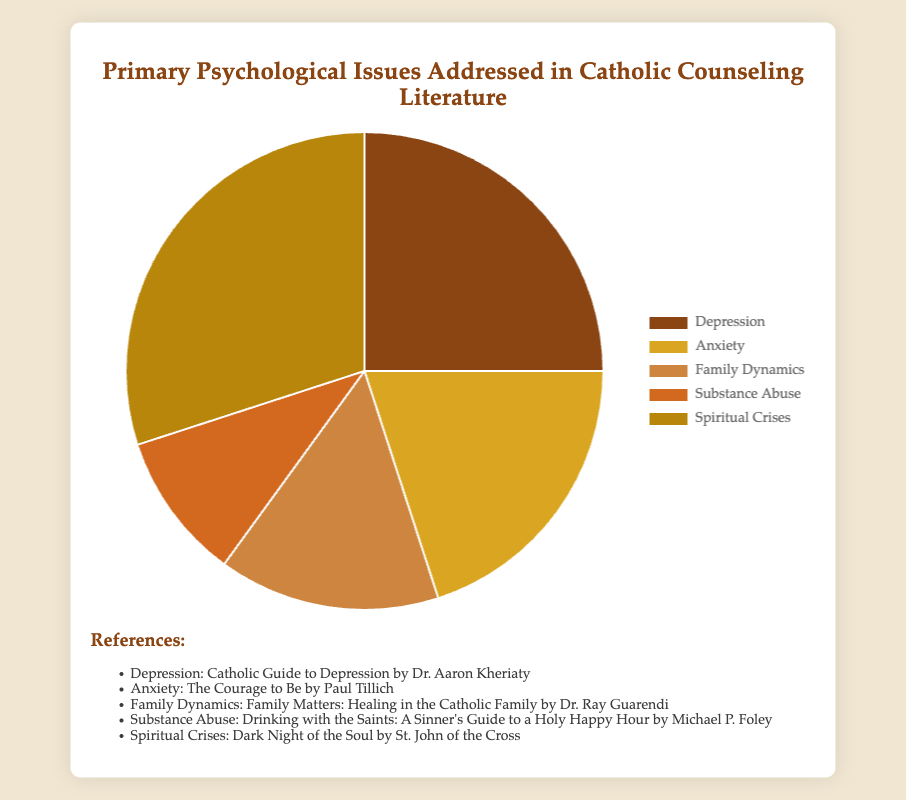Which psychological issue is addressed the most in Catholic counseling literature? The largest section of the pie chart represents Spiritual Crises, with a percentage of 30%, making it the most addressed issue.
Answer: Spiritual Crises What percentage of the pie chart is made up of Depression and Anxiety combined? To find the total percentage for Depression and Anxiety, we add their individual percentages together: 25% + 20% = 45%.
Answer: 45% Which issue is addressed less, Substance Abuse or Family Dynamics? Compare the percentages from the pie chart: Substance Abuse (10%) and Family Dynamics (15%). Substance Abuse is addressed less.
Answer: Substance Abuse By how much does the percentage addressing Spiritual Crises exceed that addressing Substance Abuse? Subtract the percentage of Substance Abuse from the percentage of Spiritual Crises: 30% - 10% = 20%.
Answer: 20% How do the percentages for Anxiety and Family Dynamics compare in terms of size? Anxiety is represented by 20% while Family Dynamics is 15%, making Anxiety 5% larger.
Answer: Anxiety is 5% larger What is the average percentage for the issues other than Spiritual Crises? Exclude Spiritual Crises and calculate the average of the remaining percentages: (25% + 20% + 15% + 10%) / 4 = 70% / 4 = 17.5%.
Answer: 17.5% Which section of the pie chart is represented in a color closest to golden or yellow? Based on the color description in the code, Anxiety is represented by Goldenrod, which is closest to golden or yellow.
Answer: Anxiety Is the percentage of Depression more or less than double the percentage of Substance Abuse? Double the percentage of Substance Abuse (10%) would be 20%. The percentage for Depression is 25% which is more than double.
Answer: More What is the total percentage represented by issues other than Spiritual Crises and Depression? Add the percentages for Anxiety (20%), Family Dynamics (15%), and Substance Abuse (10%): 20% + 15% + 10% = 45%.
Answer: 45% 